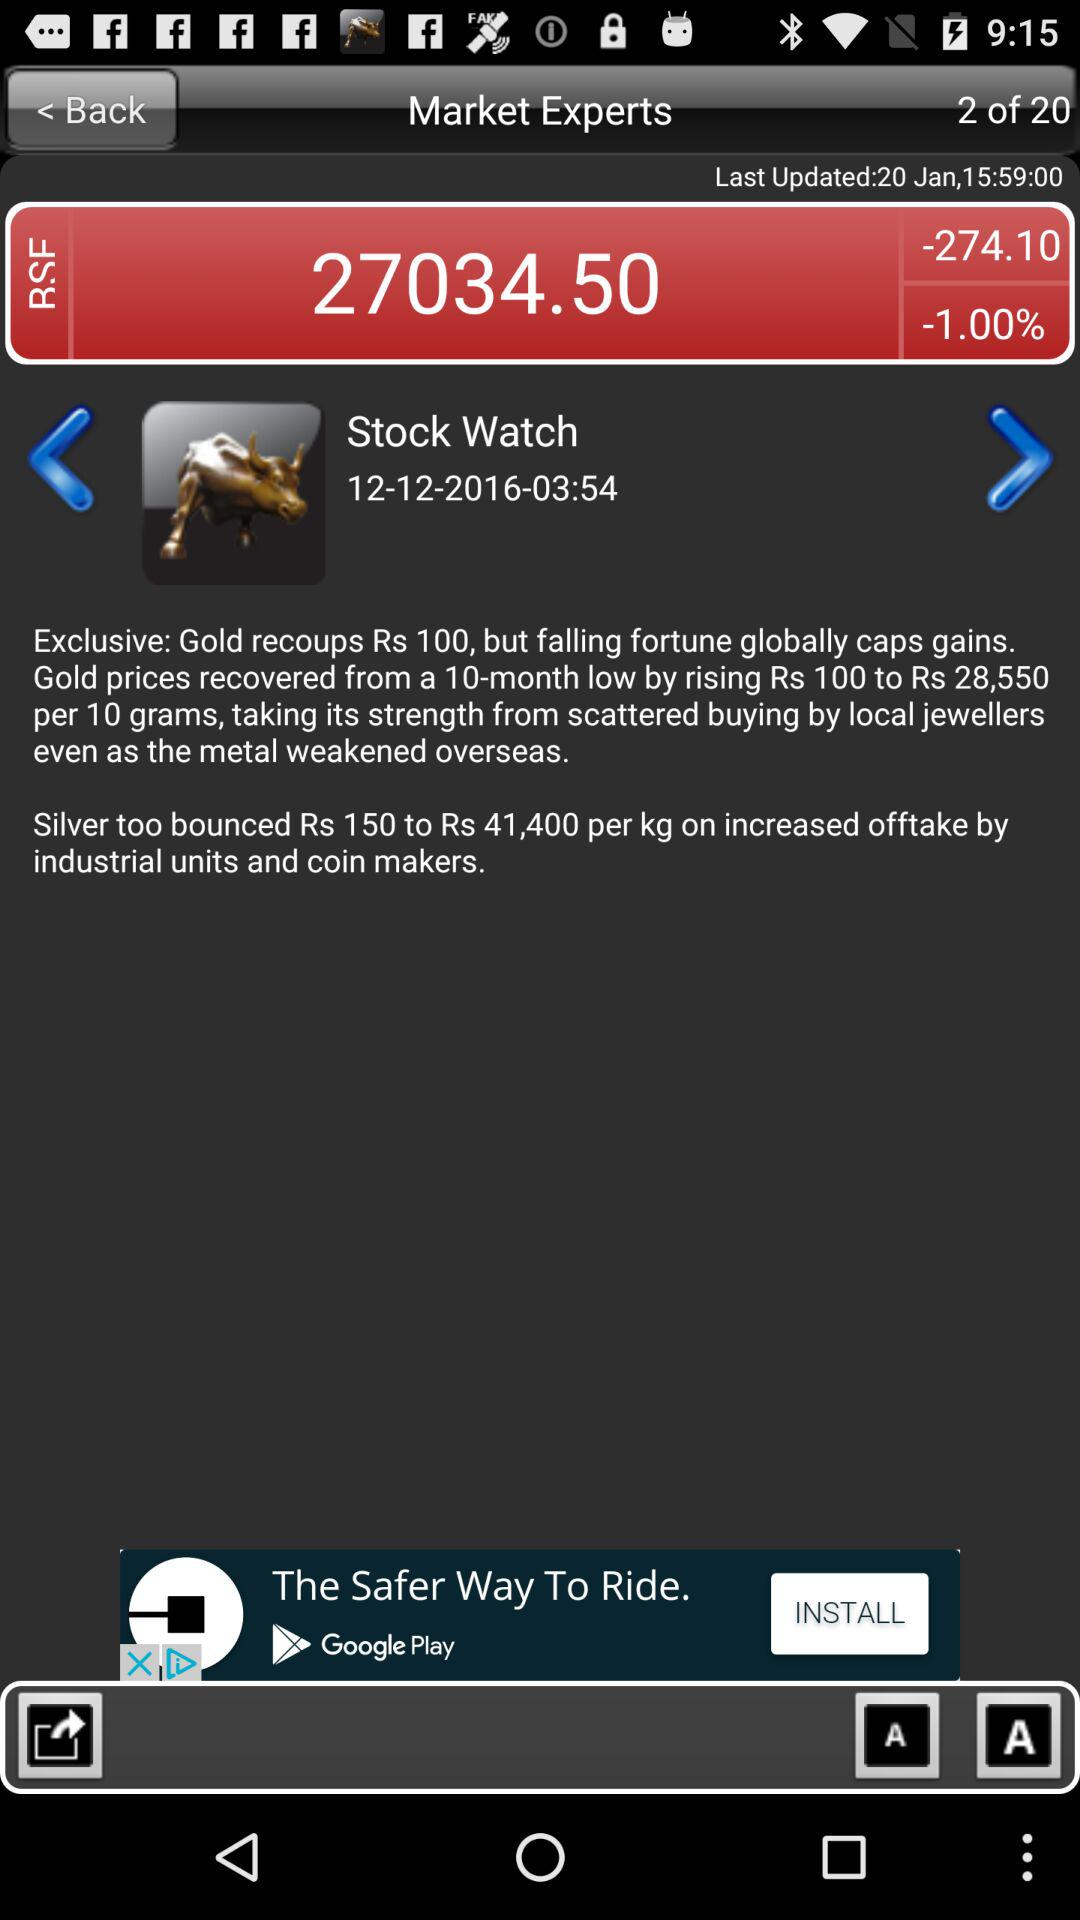What is the total number of slides? The total number of slides is 20. 